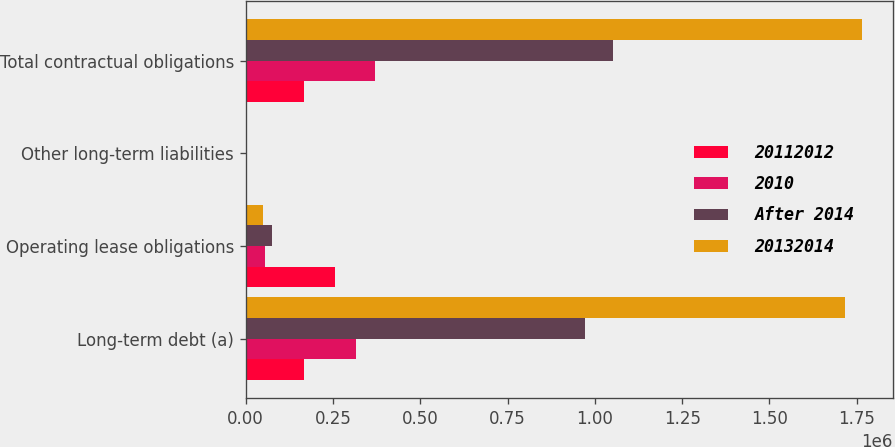Convert chart. <chart><loc_0><loc_0><loc_500><loc_500><stacked_bar_chart><ecel><fcel>Long-term debt (a)<fcel>Operating lease obligations<fcel>Other long-term liabilities<fcel>Total contractual obligations<nl><fcel>20112012<fcel>166314<fcel>256092<fcel>2337<fcel>166314<nl><fcel>2010<fcel>314937<fcel>54162<fcel>990<fcel>370089<nl><fcel>After 2014<fcel>973000<fcel>76536<fcel>1068<fcel>1.0506e+06<nl><fcel>20132014<fcel>1.71582e+06<fcel>48992<fcel>129<fcel>1.76494e+06<nl></chart> 